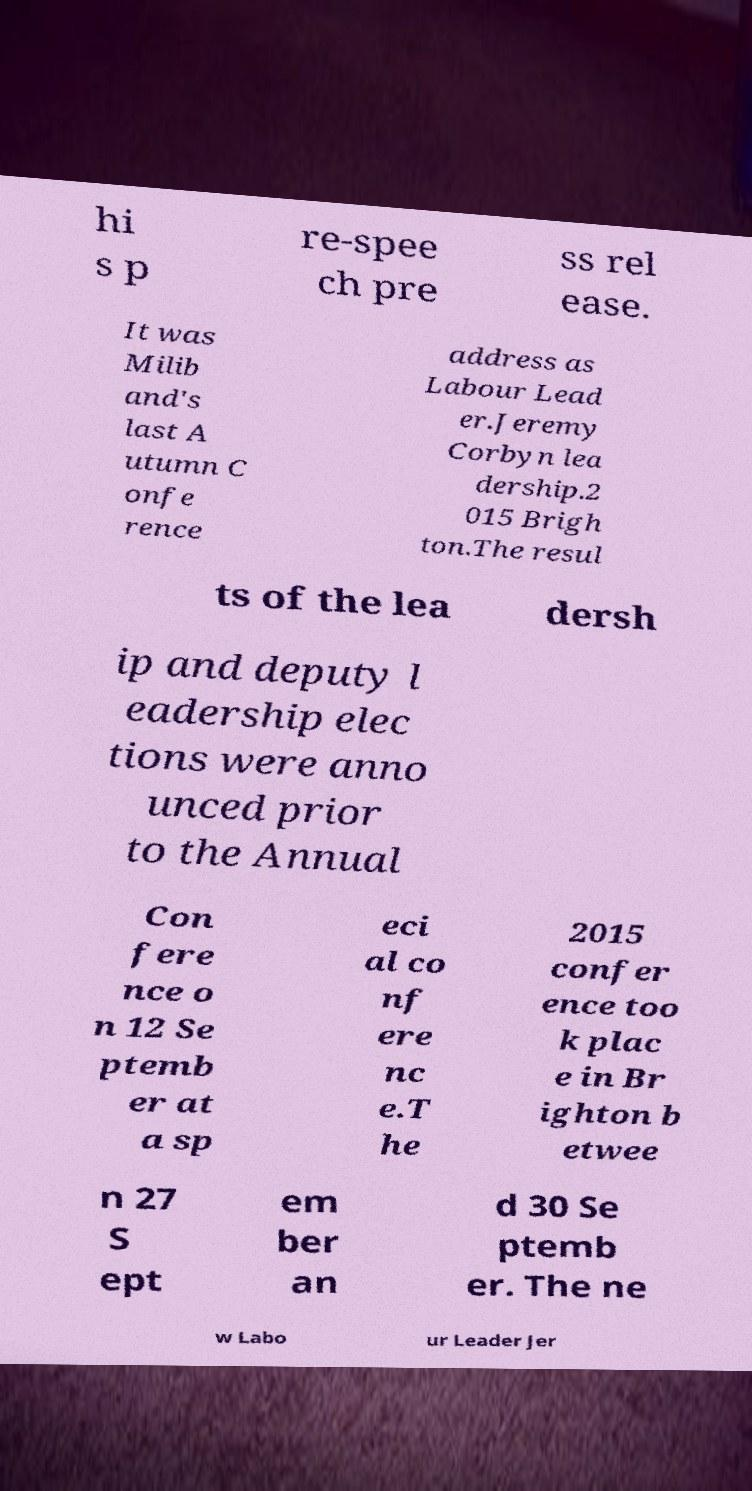For documentation purposes, I need the text within this image transcribed. Could you provide that? hi s p re-spee ch pre ss rel ease. It was Milib and's last A utumn C onfe rence address as Labour Lead er.Jeremy Corbyn lea dership.2 015 Brigh ton.The resul ts of the lea dersh ip and deputy l eadership elec tions were anno unced prior to the Annual Con fere nce o n 12 Se ptemb er at a sp eci al co nf ere nc e.T he 2015 confer ence too k plac e in Br ighton b etwee n 27 S ept em ber an d 30 Se ptemb er. The ne w Labo ur Leader Jer 